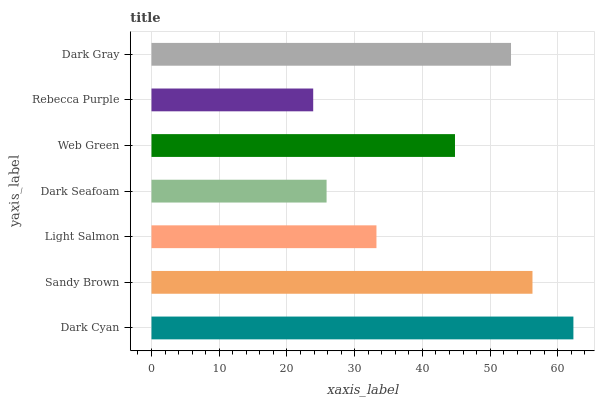Is Rebecca Purple the minimum?
Answer yes or no. Yes. Is Dark Cyan the maximum?
Answer yes or no. Yes. Is Sandy Brown the minimum?
Answer yes or no. No. Is Sandy Brown the maximum?
Answer yes or no. No. Is Dark Cyan greater than Sandy Brown?
Answer yes or no. Yes. Is Sandy Brown less than Dark Cyan?
Answer yes or no. Yes. Is Sandy Brown greater than Dark Cyan?
Answer yes or no. No. Is Dark Cyan less than Sandy Brown?
Answer yes or no. No. Is Web Green the high median?
Answer yes or no. Yes. Is Web Green the low median?
Answer yes or no. Yes. Is Dark Cyan the high median?
Answer yes or no. No. Is Dark Seafoam the low median?
Answer yes or no. No. 